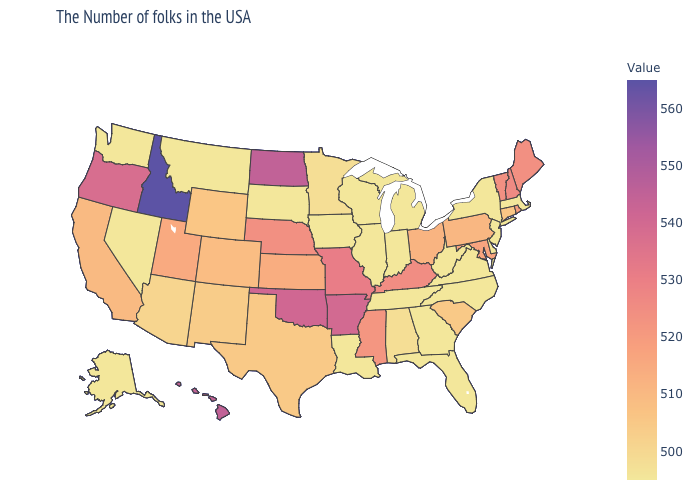Which states have the highest value in the USA?
Short answer required. Idaho. Which states have the lowest value in the MidWest?
Answer briefly. Michigan, Indiana, Wisconsin, Illinois, Iowa, South Dakota. Which states have the lowest value in the USA?
Give a very brief answer. Massachusetts, New York, New Jersey, Delaware, Virginia, North Carolina, West Virginia, Florida, Georgia, Michigan, Indiana, Tennessee, Wisconsin, Illinois, Louisiana, Iowa, South Dakota, Montana, Nevada, Washington, Alaska. Which states have the lowest value in the West?
Concise answer only. Montana, Nevada, Washington, Alaska. Which states have the lowest value in the USA?
Answer briefly. Massachusetts, New York, New Jersey, Delaware, Virginia, North Carolina, West Virginia, Florida, Georgia, Michigan, Indiana, Tennessee, Wisconsin, Illinois, Louisiana, Iowa, South Dakota, Montana, Nevada, Washington, Alaska. Does the map have missing data?
Concise answer only. No. Among the states that border Louisiana , which have the highest value?
Quick response, please. Arkansas. Among the states that border Idaho , does Montana have the highest value?
Short answer required. No. 